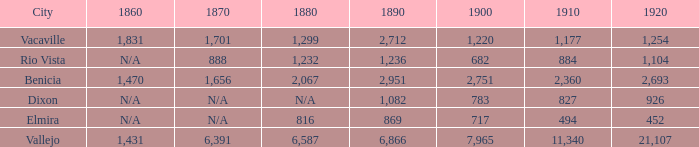What is the 1920 number when 1890 is greater than 1,236, 1910 is less than 1,177 and the city is Vacaville? None. 